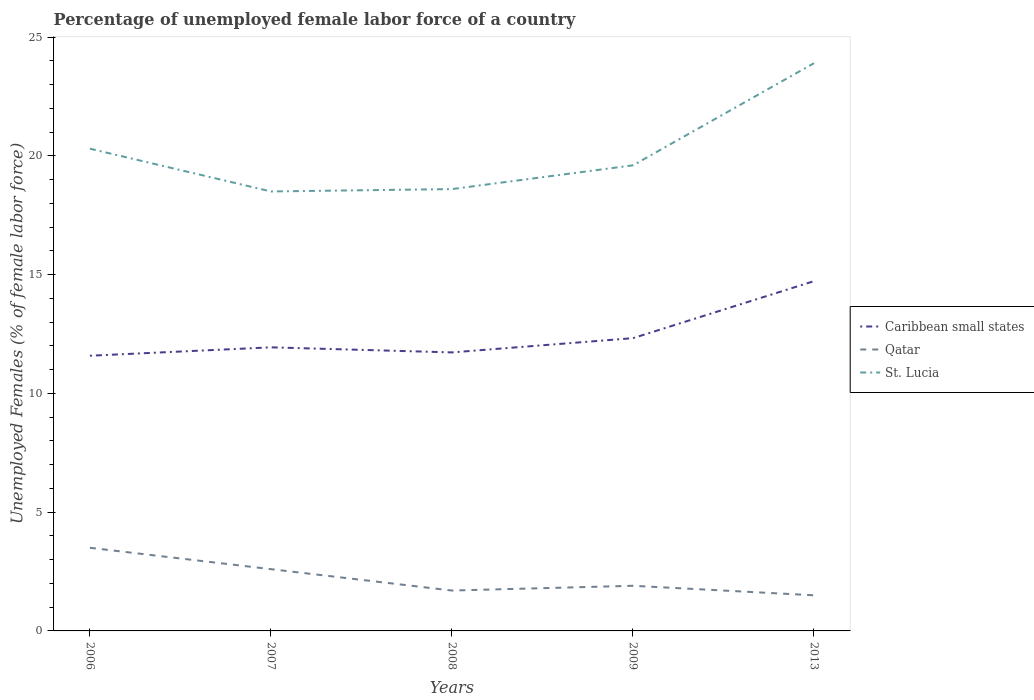How many different coloured lines are there?
Your answer should be very brief. 3. Does the line corresponding to St. Lucia intersect with the line corresponding to Caribbean small states?
Offer a very short reply. No. Is the number of lines equal to the number of legend labels?
Make the answer very short. Yes. Across all years, what is the maximum percentage of unemployed female labor force in St. Lucia?
Provide a short and direct response. 18.5. In which year was the percentage of unemployed female labor force in Qatar maximum?
Provide a short and direct response. 2013. What is the total percentage of unemployed female labor force in Caribbean small states in the graph?
Ensure brevity in your answer.  -0.35. What is the difference between the highest and the second highest percentage of unemployed female labor force in Qatar?
Offer a terse response. 2. How many lines are there?
Your answer should be very brief. 3. How many years are there in the graph?
Keep it short and to the point. 5. Are the values on the major ticks of Y-axis written in scientific E-notation?
Ensure brevity in your answer.  No. Does the graph contain grids?
Your answer should be compact. No. Where does the legend appear in the graph?
Your response must be concise. Center right. What is the title of the graph?
Provide a short and direct response. Percentage of unemployed female labor force of a country. What is the label or title of the X-axis?
Offer a very short reply. Years. What is the label or title of the Y-axis?
Your answer should be compact. Unemployed Females (% of female labor force). What is the Unemployed Females (% of female labor force) of Caribbean small states in 2006?
Your answer should be very brief. 11.58. What is the Unemployed Females (% of female labor force) of Qatar in 2006?
Your response must be concise. 3.5. What is the Unemployed Females (% of female labor force) of St. Lucia in 2006?
Your response must be concise. 20.3. What is the Unemployed Females (% of female labor force) in Caribbean small states in 2007?
Provide a short and direct response. 11.94. What is the Unemployed Females (% of female labor force) of Qatar in 2007?
Offer a terse response. 2.6. What is the Unemployed Females (% of female labor force) in Caribbean small states in 2008?
Offer a very short reply. 11.72. What is the Unemployed Females (% of female labor force) of Qatar in 2008?
Give a very brief answer. 1.7. What is the Unemployed Females (% of female labor force) of St. Lucia in 2008?
Offer a very short reply. 18.6. What is the Unemployed Females (% of female labor force) in Caribbean small states in 2009?
Keep it short and to the point. 12.32. What is the Unemployed Females (% of female labor force) in Qatar in 2009?
Your answer should be compact. 1.9. What is the Unemployed Females (% of female labor force) in St. Lucia in 2009?
Provide a short and direct response. 19.6. What is the Unemployed Females (% of female labor force) of Caribbean small states in 2013?
Provide a short and direct response. 14.72. What is the Unemployed Females (% of female labor force) of St. Lucia in 2013?
Make the answer very short. 23.9. Across all years, what is the maximum Unemployed Females (% of female labor force) in Caribbean small states?
Ensure brevity in your answer.  14.72. Across all years, what is the maximum Unemployed Females (% of female labor force) in Qatar?
Provide a short and direct response. 3.5. Across all years, what is the maximum Unemployed Females (% of female labor force) of St. Lucia?
Make the answer very short. 23.9. Across all years, what is the minimum Unemployed Females (% of female labor force) in Caribbean small states?
Provide a succinct answer. 11.58. Across all years, what is the minimum Unemployed Females (% of female labor force) of Qatar?
Provide a succinct answer. 1.5. What is the total Unemployed Females (% of female labor force) in Caribbean small states in the graph?
Provide a succinct answer. 62.3. What is the total Unemployed Females (% of female labor force) in St. Lucia in the graph?
Your response must be concise. 100.9. What is the difference between the Unemployed Females (% of female labor force) in Caribbean small states in 2006 and that in 2007?
Your answer should be very brief. -0.35. What is the difference between the Unemployed Females (% of female labor force) of Caribbean small states in 2006 and that in 2008?
Your answer should be very brief. -0.14. What is the difference between the Unemployed Females (% of female labor force) of Qatar in 2006 and that in 2008?
Offer a very short reply. 1.8. What is the difference between the Unemployed Females (% of female labor force) of St. Lucia in 2006 and that in 2008?
Provide a short and direct response. 1.7. What is the difference between the Unemployed Females (% of female labor force) of Caribbean small states in 2006 and that in 2009?
Your response must be concise. -0.74. What is the difference between the Unemployed Females (% of female labor force) of Qatar in 2006 and that in 2009?
Provide a succinct answer. 1.6. What is the difference between the Unemployed Females (% of female labor force) of St. Lucia in 2006 and that in 2009?
Ensure brevity in your answer.  0.7. What is the difference between the Unemployed Females (% of female labor force) in Caribbean small states in 2006 and that in 2013?
Your response must be concise. -3.14. What is the difference between the Unemployed Females (% of female labor force) of Qatar in 2006 and that in 2013?
Offer a terse response. 2. What is the difference between the Unemployed Females (% of female labor force) of St. Lucia in 2006 and that in 2013?
Your response must be concise. -3.6. What is the difference between the Unemployed Females (% of female labor force) in Caribbean small states in 2007 and that in 2008?
Ensure brevity in your answer.  0.21. What is the difference between the Unemployed Females (% of female labor force) of Qatar in 2007 and that in 2008?
Provide a short and direct response. 0.9. What is the difference between the Unemployed Females (% of female labor force) of St. Lucia in 2007 and that in 2008?
Give a very brief answer. -0.1. What is the difference between the Unemployed Females (% of female labor force) of Caribbean small states in 2007 and that in 2009?
Provide a short and direct response. -0.39. What is the difference between the Unemployed Females (% of female labor force) in Caribbean small states in 2007 and that in 2013?
Provide a succinct answer. -2.79. What is the difference between the Unemployed Females (% of female labor force) of Qatar in 2007 and that in 2013?
Your response must be concise. 1.1. What is the difference between the Unemployed Females (% of female labor force) of St. Lucia in 2007 and that in 2013?
Make the answer very short. -5.4. What is the difference between the Unemployed Females (% of female labor force) in Caribbean small states in 2008 and that in 2009?
Your response must be concise. -0.6. What is the difference between the Unemployed Females (% of female labor force) in Caribbean small states in 2009 and that in 2013?
Offer a terse response. -2.4. What is the difference between the Unemployed Females (% of female labor force) in St. Lucia in 2009 and that in 2013?
Ensure brevity in your answer.  -4.3. What is the difference between the Unemployed Females (% of female labor force) in Caribbean small states in 2006 and the Unemployed Females (% of female labor force) in Qatar in 2007?
Give a very brief answer. 8.98. What is the difference between the Unemployed Females (% of female labor force) in Caribbean small states in 2006 and the Unemployed Females (% of female labor force) in St. Lucia in 2007?
Offer a very short reply. -6.92. What is the difference between the Unemployed Females (% of female labor force) in Qatar in 2006 and the Unemployed Females (% of female labor force) in St. Lucia in 2007?
Keep it short and to the point. -15. What is the difference between the Unemployed Females (% of female labor force) in Caribbean small states in 2006 and the Unemployed Females (% of female labor force) in Qatar in 2008?
Give a very brief answer. 9.88. What is the difference between the Unemployed Females (% of female labor force) of Caribbean small states in 2006 and the Unemployed Females (% of female labor force) of St. Lucia in 2008?
Your answer should be compact. -7.01. What is the difference between the Unemployed Females (% of female labor force) in Qatar in 2006 and the Unemployed Females (% of female labor force) in St. Lucia in 2008?
Your response must be concise. -15.1. What is the difference between the Unemployed Females (% of female labor force) in Caribbean small states in 2006 and the Unemployed Females (% of female labor force) in Qatar in 2009?
Offer a very short reply. 9.69. What is the difference between the Unemployed Females (% of female labor force) in Caribbean small states in 2006 and the Unemployed Females (% of female labor force) in St. Lucia in 2009?
Your answer should be compact. -8.02. What is the difference between the Unemployed Females (% of female labor force) of Qatar in 2006 and the Unemployed Females (% of female labor force) of St. Lucia in 2009?
Make the answer very short. -16.1. What is the difference between the Unemployed Females (% of female labor force) of Caribbean small states in 2006 and the Unemployed Females (% of female labor force) of Qatar in 2013?
Keep it short and to the point. 10.09. What is the difference between the Unemployed Females (% of female labor force) in Caribbean small states in 2006 and the Unemployed Females (% of female labor force) in St. Lucia in 2013?
Your response must be concise. -12.31. What is the difference between the Unemployed Females (% of female labor force) in Qatar in 2006 and the Unemployed Females (% of female labor force) in St. Lucia in 2013?
Make the answer very short. -20.4. What is the difference between the Unemployed Females (% of female labor force) of Caribbean small states in 2007 and the Unemployed Females (% of female labor force) of Qatar in 2008?
Your response must be concise. 10.24. What is the difference between the Unemployed Females (% of female labor force) in Caribbean small states in 2007 and the Unemployed Females (% of female labor force) in St. Lucia in 2008?
Offer a very short reply. -6.66. What is the difference between the Unemployed Females (% of female labor force) in Caribbean small states in 2007 and the Unemployed Females (% of female labor force) in Qatar in 2009?
Keep it short and to the point. 10.04. What is the difference between the Unemployed Females (% of female labor force) in Caribbean small states in 2007 and the Unemployed Females (% of female labor force) in St. Lucia in 2009?
Keep it short and to the point. -7.66. What is the difference between the Unemployed Females (% of female labor force) in Qatar in 2007 and the Unemployed Females (% of female labor force) in St. Lucia in 2009?
Keep it short and to the point. -17. What is the difference between the Unemployed Females (% of female labor force) of Caribbean small states in 2007 and the Unemployed Females (% of female labor force) of Qatar in 2013?
Offer a very short reply. 10.44. What is the difference between the Unemployed Females (% of female labor force) in Caribbean small states in 2007 and the Unemployed Females (% of female labor force) in St. Lucia in 2013?
Your response must be concise. -11.96. What is the difference between the Unemployed Females (% of female labor force) of Qatar in 2007 and the Unemployed Females (% of female labor force) of St. Lucia in 2013?
Your answer should be compact. -21.3. What is the difference between the Unemployed Females (% of female labor force) in Caribbean small states in 2008 and the Unemployed Females (% of female labor force) in Qatar in 2009?
Your response must be concise. 9.82. What is the difference between the Unemployed Females (% of female labor force) in Caribbean small states in 2008 and the Unemployed Females (% of female labor force) in St. Lucia in 2009?
Offer a very short reply. -7.88. What is the difference between the Unemployed Females (% of female labor force) of Qatar in 2008 and the Unemployed Females (% of female labor force) of St. Lucia in 2009?
Your answer should be compact. -17.9. What is the difference between the Unemployed Females (% of female labor force) in Caribbean small states in 2008 and the Unemployed Females (% of female labor force) in Qatar in 2013?
Keep it short and to the point. 10.22. What is the difference between the Unemployed Females (% of female labor force) in Caribbean small states in 2008 and the Unemployed Females (% of female labor force) in St. Lucia in 2013?
Your answer should be very brief. -12.18. What is the difference between the Unemployed Females (% of female labor force) of Qatar in 2008 and the Unemployed Females (% of female labor force) of St. Lucia in 2013?
Make the answer very short. -22.2. What is the difference between the Unemployed Females (% of female labor force) in Caribbean small states in 2009 and the Unemployed Females (% of female labor force) in Qatar in 2013?
Give a very brief answer. 10.82. What is the difference between the Unemployed Females (% of female labor force) of Caribbean small states in 2009 and the Unemployed Females (% of female labor force) of St. Lucia in 2013?
Your answer should be compact. -11.58. What is the average Unemployed Females (% of female labor force) of Caribbean small states per year?
Ensure brevity in your answer.  12.46. What is the average Unemployed Females (% of female labor force) in Qatar per year?
Your answer should be very brief. 2.24. What is the average Unemployed Females (% of female labor force) in St. Lucia per year?
Provide a short and direct response. 20.18. In the year 2006, what is the difference between the Unemployed Females (% of female labor force) of Caribbean small states and Unemployed Females (% of female labor force) of Qatar?
Your response must be concise. 8.09. In the year 2006, what is the difference between the Unemployed Females (% of female labor force) of Caribbean small states and Unemployed Females (% of female labor force) of St. Lucia?
Make the answer very short. -8.71. In the year 2006, what is the difference between the Unemployed Females (% of female labor force) in Qatar and Unemployed Females (% of female labor force) in St. Lucia?
Make the answer very short. -16.8. In the year 2007, what is the difference between the Unemployed Females (% of female labor force) in Caribbean small states and Unemployed Females (% of female labor force) in Qatar?
Offer a terse response. 9.34. In the year 2007, what is the difference between the Unemployed Females (% of female labor force) of Caribbean small states and Unemployed Females (% of female labor force) of St. Lucia?
Keep it short and to the point. -6.56. In the year 2007, what is the difference between the Unemployed Females (% of female labor force) of Qatar and Unemployed Females (% of female labor force) of St. Lucia?
Offer a very short reply. -15.9. In the year 2008, what is the difference between the Unemployed Females (% of female labor force) in Caribbean small states and Unemployed Females (% of female labor force) in Qatar?
Keep it short and to the point. 10.02. In the year 2008, what is the difference between the Unemployed Females (% of female labor force) in Caribbean small states and Unemployed Females (% of female labor force) in St. Lucia?
Make the answer very short. -6.88. In the year 2008, what is the difference between the Unemployed Females (% of female labor force) in Qatar and Unemployed Females (% of female labor force) in St. Lucia?
Offer a terse response. -16.9. In the year 2009, what is the difference between the Unemployed Females (% of female labor force) in Caribbean small states and Unemployed Females (% of female labor force) in Qatar?
Make the answer very short. 10.42. In the year 2009, what is the difference between the Unemployed Females (% of female labor force) of Caribbean small states and Unemployed Females (% of female labor force) of St. Lucia?
Give a very brief answer. -7.28. In the year 2009, what is the difference between the Unemployed Females (% of female labor force) of Qatar and Unemployed Females (% of female labor force) of St. Lucia?
Offer a very short reply. -17.7. In the year 2013, what is the difference between the Unemployed Females (% of female labor force) of Caribbean small states and Unemployed Females (% of female labor force) of Qatar?
Your answer should be very brief. 13.22. In the year 2013, what is the difference between the Unemployed Females (% of female labor force) of Caribbean small states and Unemployed Females (% of female labor force) of St. Lucia?
Provide a succinct answer. -9.18. In the year 2013, what is the difference between the Unemployed Females (% of female labor force) of Qatar and Unemployed Females (% of female labor force) of St. Lucia?
Ensure brevity in your answer.  -22.4. What is the ratio of the Unemployed Females (% of female labor force) of Caribbean small states in 2006 to that in 2007?
Your response must be concise. 0.97. What is the ratio of the Unemployed Females (% of female labor force) in Qatar in 2006 to that in 2007?
Keep it short and to the point. 1.35. What is the ratio of the Unemployed Females (% of female labor force) in St. Lucia in 2006 to that in 2007?
Provide a succinct answer. 1.1. What is the ratio of the Unemployed Females (% of female labor force) in Qatar in 2006 to that in 2008?
Offer a terse response. 2.06. What is the ratio of the Unemployed Females (% of female labor force) in St. Lucia in 2006 to that in 2008?
Offer a very short reply. 1.09. What is the ratio of the Unemployed Females (% of female labor force) of Caribbean small states in 2006 to that in 2009?
Offer a very short reply. 0.94. What is the ratio of the Unemployed Females (% of female labor force) in Qatar in 2006 to that in 2009?
Keep it short and to the point. 1.84. What is the ratio of the Unemployed Females (% of female labor force) of St. Lucia in 2006 to that in 2009?
Ensure brevity in your answer.  1.04. What is the ratio of the Unemployed Females (% of female labor force) of Caribbean small states in 2006 to that in 2013?
Your response must be concise. 0.79. What is the ratio of the Unemployed Females (% of female labor force) in Qatar in 2006 to that in 2013?
Provide a short and direct response. 2.33. What is the ratio of the Unemployed Females (% of female labor force) of St. Lucia in 2006 to that in 2013?
Give a very brief answer. 0.85. What is the ratio of the Unemployed Females (% of female labor force) in Caribbean small states in 2007 to that in 2008?
Your response must be concise. 1.02. What is the ratio of the Unemployed Females (% of female labor force) of Qatar in 2007 to that in 2008?
Ensure brevity in your answer.  1.53. What is the ratio of the Unemployed Females (% of female labor force) of St. Lucia in 2007 to that in 2008?
Give a very brief answer. 0.99. What is the ratio of the Unemployed Females (% of female labor force) of Caribbean small states in 2007 to that in 2009?
Offer a terse response. 0.97. What is the ratio of the Unemployed Females (% of female labor force) of Qatar in 2007 to that in 2009?
Provide a short and direct response. 1.37. What is the ratio of the Unemployed Females (% of female labor force) of St. Lucia in 2007 to that in 2009?
Your response must be concise. 0.94. What is the ratio of the Unemployed Females (% of female labor force) of Caribbean small states in 2007 to that in 2013?
Provide a short and direct response. 0.81. What is the ratio of the Unemployed Females (% of female labor force) in Qatar in 2007 to that in 2013?
Your answer should be very brief. 1.73. What is the ratio of the Unemployed Females (% of female labor force) of St. Lucia in 2007 to that in 2013?
Offer a terse response. 0.77. What is the ratio of the Unemployed Females (% of female labor force) in Caribbean small states in 2008 to that in 2009?
Make the answer very short. 0.95. What is the ratio of the Unemployed Females (% of female labor force) in Qatar in 2008 to that in 2009?
Your answer should be very brief. 0.89. What is the ratio of the Unemployed Females (% of female labor force) of St. Lucia in 2008 to that in 2009?
Offer a very short reply. 0.95. What is the ratio of the Unemployed Females (% of female labor force) in Caribbean small states in 2008 to that in 2013?
Make the answer very short. 0.8. What is the ratio of the Unemployed Females (% of female labor force) in Qatar in 2008 to that in 2013?
Your response must be concise. 1.13. What is the ratio of the Unemployed Females (% of female labor force) of St. Lucia in 2008 to that in 2013?
Provide a short and direct response. 0.78. What is the ratio of the Unemployed Females (% of female labor force) in Caribbean small states in 2009 to that in 2013?
Provide a succinct answer. 0.84. What is the ratio of the Unemployed Females (% of female labor force) of Qatar in 2009 to that in 2013?
Make the answer very short. 1.27. What is the ratio of the Unemployed Females (% of female labor force) in St. Lucia in 2009 to that in 2013?
Provide a short and direct response. 0.82. What is the difference between the highest and the second highest Unemployed Females (% of female labor force) of Caribbean small states?
Provide a succinct answer. 2.4. What is the difference between the highest and the lowest Unemployed Females (% of female labor force) in Caribbean small states?
Ensure brevity in your answer.  3.14. What is the difference between the highest and the lowest Unemployed Females (% of female labor force) of St. Lucia?
Make the answer very short. 5.4. 